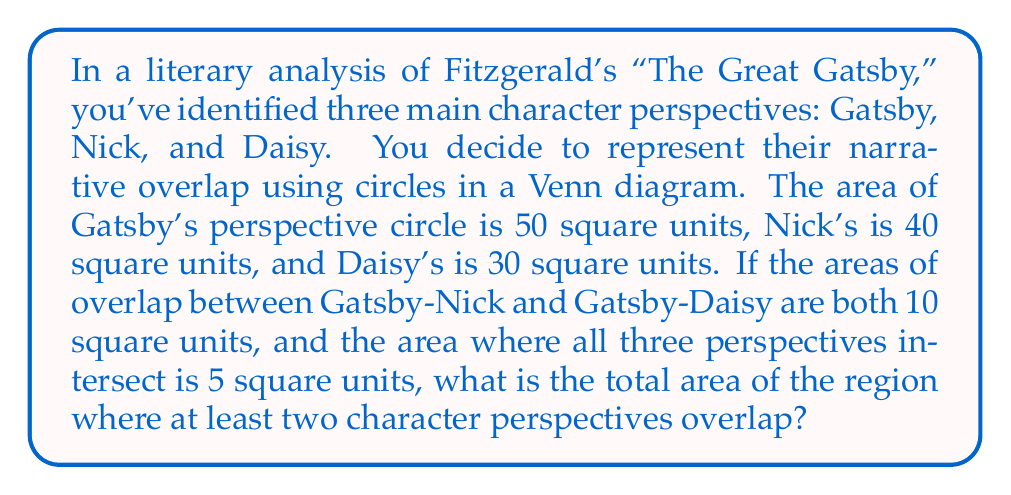Show me your answer to this math problem. Let's approach this step-by-step:

1) First, let's visualize the problem using a Venn diagram:

[asy]
unitsize(1cm);

pair A = (0,0), B = (1.5,2), C = (3,0);
real r1 = 2, r2 = 1.8, r3 = 1.6;

path c1 = circle(A, r1);
path c2 = circle(B, r2);
path c3 = circle(C, r3);

fill(c1, rgb(1,0.7,0.7));
fill(c2, rgb(0.7,1,0.7));
fill(c3, rgb(0.7,0.7,1));

draw(c1);
draw(c2);
draw(c3);

label("Gatsby", A, SW);
label("Nick", B, N);
label("Daisy", C, SE);

label("10", (A+B)/2);
label("10", (A+C)/2);
label("5", (A+B+C)/3);
[/asy]

2) Let's define our variables:
   $G$: Gatsby's perspective
   $N$: Nick's perspective
   $D$: Daisy's perspective

3) We're given:
   $|G| = 50$, $|N| = 40$, $|D| = 30$
   $|G \cap N| = 10$, $|G \cap D| = 10$
   $|G \cap N \cap D| = 5$

4) We need to find the total area where at least two perspectives overlap. This can be expressed as:
   $|G \cap N| + |G \cap D| + |N \cap D| - 2|G \cap N \cap D|$

5) We know $|G \cap N|$, $|G \cap D|$, and $|G \cap N \cap D|$, but we don't know $|N \cap D|$. We can find this using the inclusion-exclusion principle:

   $|G \cup N \cup D| = |G| + |N| + |D| - |G \cap N| - |G \cap D| - |N \cap D| + |G \cap N \cap D|$

6) We can calculate $|G \cup N \cup D|$ by subtracting the overlapping areas from the sum of individual areas:

   $|G \cup N \cup D| = 50 + 40 + 30 - 10 - 10 - 5 = 95$

7) Now we can solve for $|N \cap D|$:

   $95 = 50 + 40 + 30 - 10 - 10 - |N \cap D| + 5$
   $95 = 105 - |N \cap D|$
   $|N \cap D| = 10$

8) Now we have all the pieces to calculate the total overlapping area:

   Total overlap = $|G \cap N| + |G \cap D| + |N \cap D| - 2|G \cap N \cap D|$
                 = $10 + 10 + 10 - 2(5)$
                 = $30 - 10$
                 = $20$
Answer: The total area where at least two character perspectives overlap is 20 square units. 